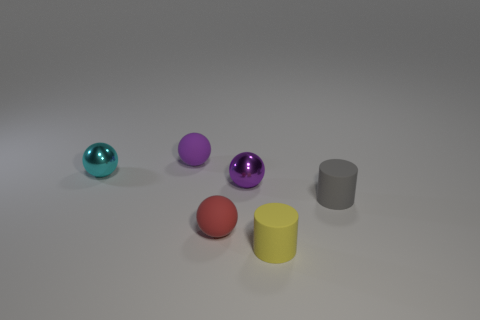How many other things are the same shape as the purple matte thing?
Offer a terse response. 3. What is the shape of the metallic object to the right of the red sphere?
Your answer should be compact. Sphere. Are there any purple balls that have the same material as the cyan ball?
Your answer should be very brief. Yes. There is a red matte thing on the right side of the small purple object left of the purple shiny thing; are there any matte objects right of it?
Make the answer very short. Yes. There is a tiny yellow cylinder; what number of small gray cylinders are behind it?
Make the answer very short. 1. What number of objects are small rubber objects that are behind the cyan metal ball or tiny purple balls on the left side of the red rubber sphere?
Give a very brief answer. 1. Are there more small purple balls than matte things?
Ensure brevity in your answer.  No. What is the color of the tiny matte sphere behind the tiny gray matte cylinder?
Offer a very short reply. Purple. Do the tiny gray matte thing and the yellow thing have the same shape?
Your answer should be compact. Yes. There is a small rubber object that is on the right side of the small red ball and in front of the gray object; what is its color?
Your answer should be compact. Yellow. 